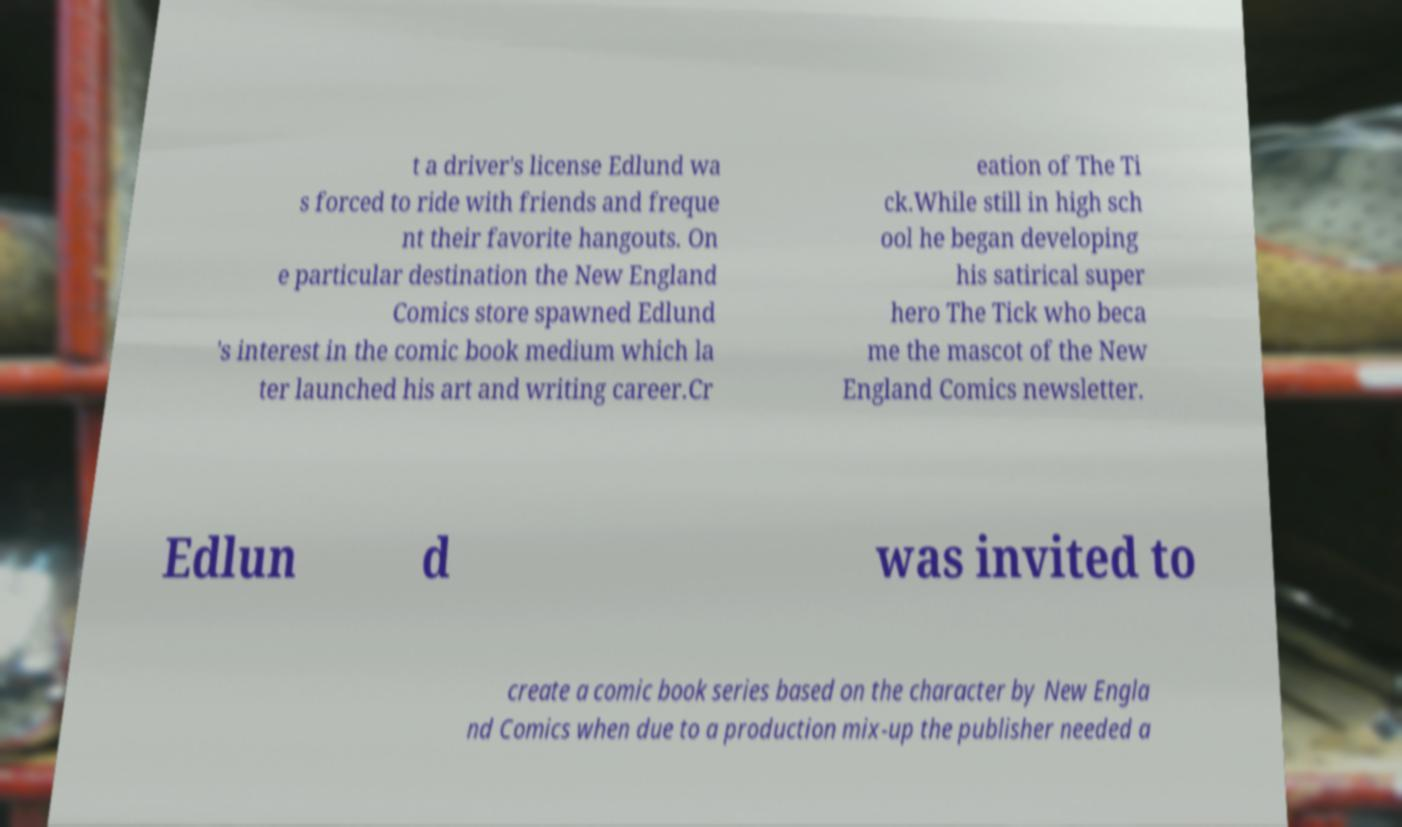Please read and relay the text visible in this image. What does it say? t a driver's license Edlund wa s forced to ride with friends and freque nt their favorite hangouts. On e particular destination the New England Comics store spawned Edlund 's interest in the comic book medium which la ter launched his art and writing career.Cr eation of The Ti ck.While still in high sch ool he began developing his satirical super hero The Tick who beca me the mascot of the New England Comics newsletter. Edlun d was invited to create a comic book series based on the character by New Engla nd Comics when due to a production mix-up the publisher needed a 